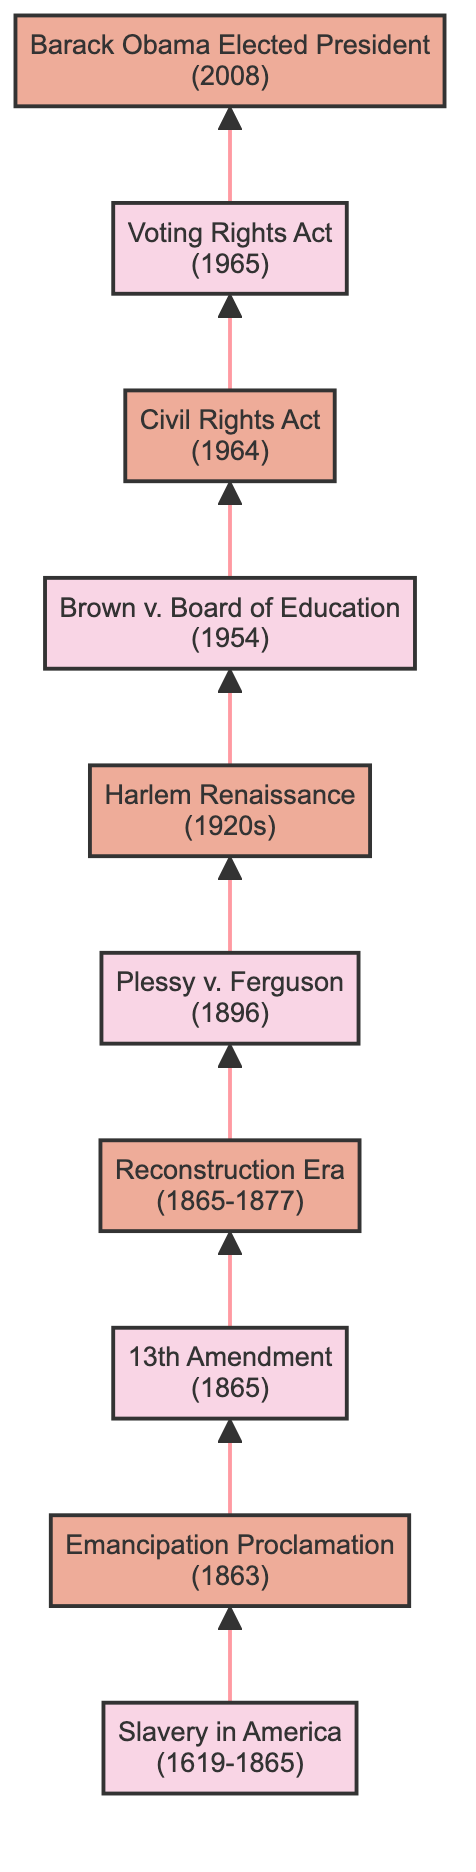What is the first milestone in the flow chart? The first milestone depicted in the diagram is "Slavery in America," which is the starting point of the historical timeline.
Answer: Slavery in America How many major milestones are listed in the diagram? By counting the distinct milestones illustrated in the chart, there are ten individual milestones detailing significant events and legislative acts in African American history.
Answer: 10 What milestone follows the Emancipation Proclamation? The milestone immediately following the "Emancipation Proclamation" is the "13th Amendment," which abolished slavery throughout the United States.
Answer: 13th Amendment Which milestone occurs in 1964? In the diagram, the milestone that takes place in 1964 is the "Civil Rights Act," which outlawed discrimination based on race, color, religion, sex, or national origin.
Answer: Civil Rights Act What is the relationship between the "Brown v. Board of Education" and the "Civil Rights Act"? "Brown v. Board of Education," which occurred in 1954, contributed to the civil rights movement leading up to the "Civil Rights Act" in 1964, as it declared segregation in public schools unconstitutional.
Answer: Contributing events What major event is represented by a landmark Supreme Court decision in 1954? The event represented in 1954 by a landmark Supreme Court decision is "Brown v. Board of Education," which addressed segregation in education.
Answer: Brown v. Board of Education What years mark the Reconstruction Era? The Reconstruction Era is marked by the years 1865 to 1877, as shown in the timeline reflecting the post-Civil War rebuilding phase in Southern states.
Answer: 1865-1877 What significant cultural movement is noted in the 1920s? The significant cultural movement noted in the 1920s is the "Harlem Renaissance," which was a flourishing time for African American arts and culture centered in Harlem, New York City.
Answer: Harlem Renaissance What major milestone occurred in 2008? The major milestone in 2008 is the election of Barack Obama as President of the United States, representing an important historic achievement for African Americans.
Answer: Barack Obama Elected President 